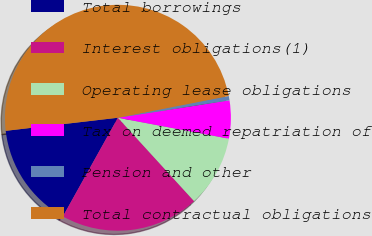<chart> <loc_0><loc_0><loc_500><loc_500><pie_chart><fcel>Total borrowings<fcel>Interest obligations(1)<fcel>Operating lease obligations<fcel>Tax on deemed repatriation of<fcel>Pension and other<fcel>Total contractual obligations<nl><fcel>15.06%<fcel>19.88%<fcel>10.25%<fcel>5.43%<fcel>0.62%<fcel>48.77%<nl></chart> 